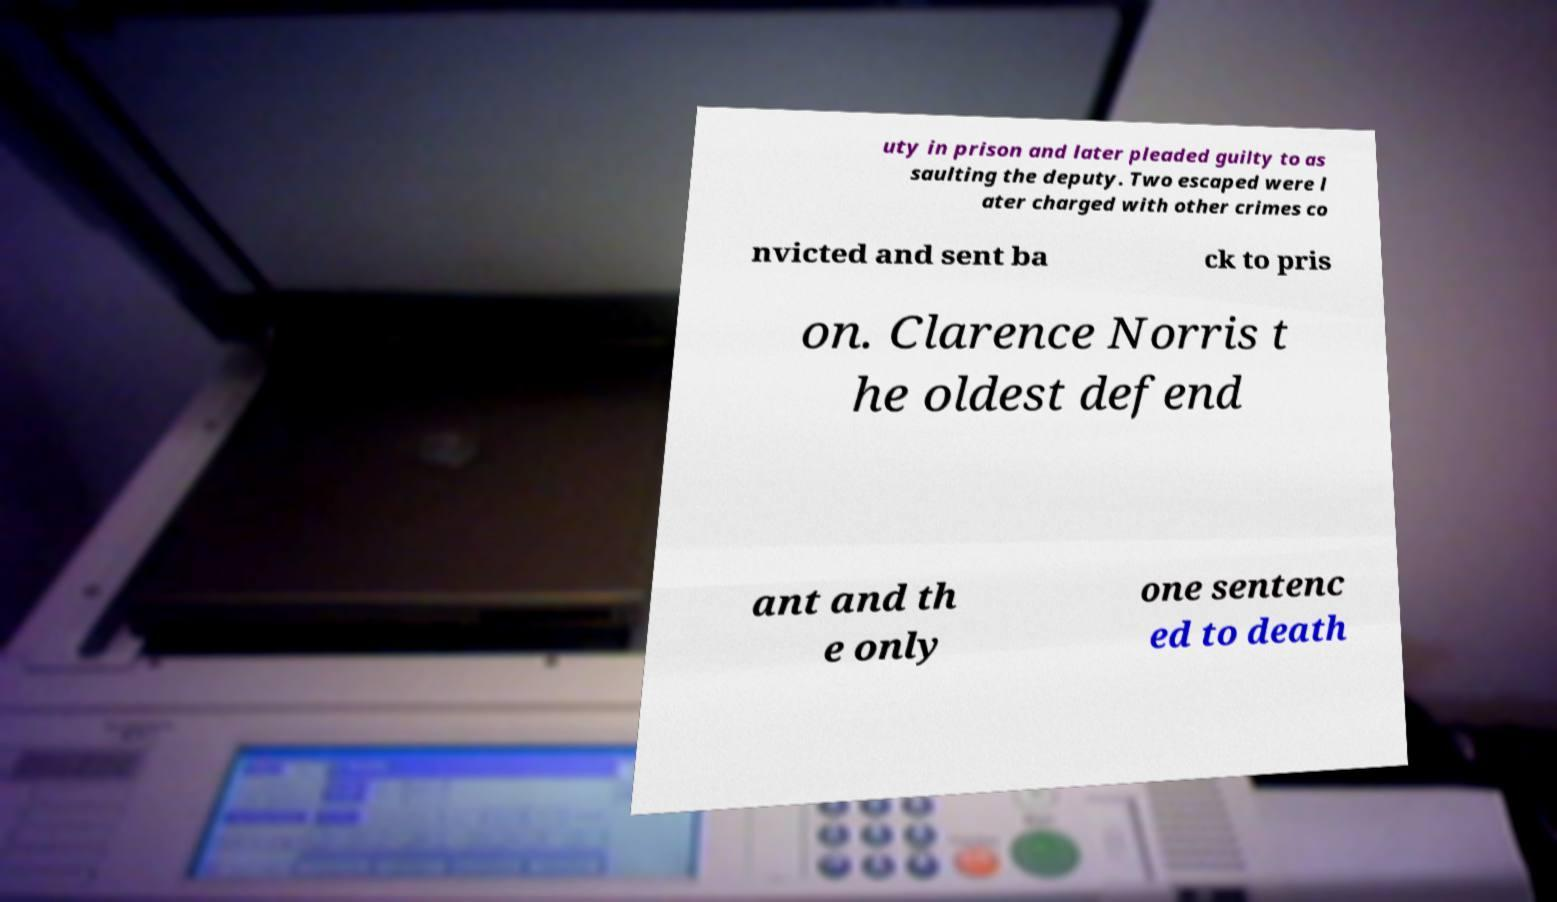Please read and relay the text visible in this image. What does it say? uty in prison and later pleaded guilty to as saulting the deputy. Two escaped were l ater charged with other crimes co nvicted and sent ba ck to pris on. Clarence Norris t he oldest defend ant and th e only one sentenc ed to death 